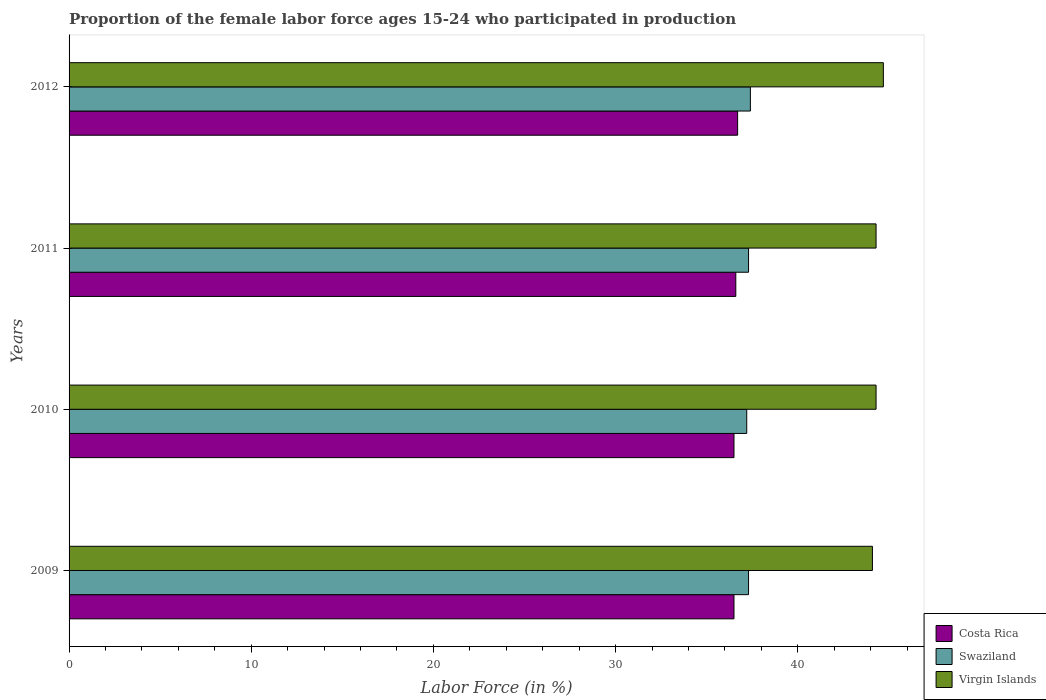How many different coloured bars are there?
Make the answer very short. 3. How many groups of bars are there?
Provide a succinct answer. 4. How many bars are there on the 4th tick from the top?
Provide a short and direct response. 3. How many bars are there on the 4th tick from the bottom?
Offer a terse response. 3. What is the proportion of the female labor force who participated in production in Virgin Islands in 2009?
Make the answer very short. 44.1. Across all years, what is the maximum proportion of the female labor force who participated in production in Virgin Islands?
Offer a very short reply. 44.7. Across all years, what is the minimum proportion of the female labor force who participated in production in Swaziland?
Your response must be concise. 37.2. In which year was the proportion of the female labor force who participated in production in Swaziland maximum?
Ensure brevity in your answer.  2012. In which year was the proportion of the female labor force who participated in production in Costa Rica minimum?
Your answer should be compact. 2009. What is the total proportion of the female labor force who participated in production in Costa Rica in the graph?
Your answer should be compact. 146.3. What is the difference between the proportion of the female labor force who participated in production in Swaziland in 2010 and the proportion of the female labor force who participated in production in Virgin Islands in 2012?
Your response must be concise. -7.5. What is the average proportion of the female labor force who participated in production in Virgin Islands per year?
Provide a short and direct response. 44.35. In the year 2012, what is the difference between the proportion of the female labor force who participated in production in Costa Rica and proportion of the female labor force who participated in production in Swaziland?
Give a very brief answer. -0.7. What is the ratio of the proportion of the female labor force who participated in production in Virgin Islands in 2011 to that in 2012?
Keep it short and to the point. 0.99. Is the difference between the proportion of the female labor force who participated in production in Costa Rica in 2009 and 2012 greater than the difference between the proportion of the female labor force who participated in production in Swaziland in 2009 and 2012?
Your response must be concise. No. What is the difference between the highest and the second highest proportion of the female labor force who participated in production in Virgin Islands?
Your answer should be compact. 0.4. What is the difference between the highest and the lowest proportion of the female labor force who participated in production in Swaziland?
Your answer should be very brief. 0.2. In how many years, is the proportion of the female labor force who participated in production in Virgin Islands greater than the average proportion of the female labor force who participated in production in Virgin Islands taken over all years?
Provide a succinct answer. 1. Is the sum of the proportion of the female labor force who participated in production in Swaziland in 2010 and 2012 greater than the maximum proportion of the female labor force who participated in production in Virgin Islands across all years?
Ensure brevity in your answer.  Yes. What does the 1st bar from the bottom in 2009 represents?
Ensure brevity in your answer.  Costa Rica. How many years are there in the graph?
Your answer should be very brief. 4. What is the difference between two consecutive major ticks on the X-axis?
Make the answer very short. 10. Does the graph contain grids?
Make the answer very short. No. How many legend labels are there?
Give a very brief answer. 3. What is the title of the graph?
Provide a short and direct response. Proportion of the female labor force ages 15-24 who participated in production. Does "Kosovo" appear as one of the legend labels in the graph?
Make the answer very short. No. What is the label or title of the Y-axis?
Keep it short and to the point. Years. What is the Labor Force (in %) of Costa Rica in 2009?
Ensure brevity in your answer.  36.5. What is the Labor Force (in %) in Swaziland in 2009?
Give a very brief answer. 37.3. What is the Labor Force (in %) of Virgin Islands in 2009?
Ensure brevity in your answer.  44.1. What is the Labor Force (in %) in Costa Rica in 2010?
Your answer should be very brief. 36.5. What is the Labor Force (in %) of Swaziland in 2010?
Offer a very short reply. 37.2. What is the Labor Force (in %) of Virgin Islands in 2010?
Give a very brief answer. 44.3. What is the Labor Force (in %) in Costa Rica in 2011?
Make the answer very short. 36.6. What is the Labor Force (in %) in Swaziland in 2011?
Give a very brief answer. 37.3. What is the Labor Force (in %) of Virgin Islands in 2011?
Offer a very short reply. 44.3. What is the Labor Force (in %) of Costa Rica in 2012?
Give a very brief answer. 36.7. What is the Labor Force (in %) in Swaziland in 2012?
Your answer should be compact. 37.4. What is the Labor Force (in %) of Virgin Islands in 2012?
Give a very brief answer. 44.7. Across all years, what is the maximum Labor Force (in %) of Costa Rica?
Make the answer very short. 36.7. Across all years, what is the maximum Labor Force (in %) of Swaziland?
Make the answer very short. 37.4. Across all years, what is the maximum Labor Force (in %) in Virgin Islands?
Your answer should be very brief. 44.7. Across all years, what is the minimum Labor Force (in %) in Costa Rica?
Your answer should be compact. 36.5. Across all years, what is the minimum Labor Force (in %) in Swaziland?
Keep it short and to the point. 37.2. Across all years, what is the minimum Labor Force (in %) in Virgin Islands?
Your answer should be compact. 44.1. What is the total Labor Force (in %) in Costa Rica in the graph?
Ensure brevity in your answer.  146.3. What is the total Labor Force (in %) in Swaziland in the graph?
Offer a terse response. 149.2. What is the total Labor Force (in %) of Virgin Islands in the graph?
Ensure brevity in your answer.  177.4. What is the difference between the Labor Force (in %) of Costa Rica in 2009 and that in 2010?
Provide a short and direct response. 0. What is the difference between the Labor Force (in %) in Swaziland in 2009 and that in 2010?
Offer a terse response. 0.1. What is the difference between the Labor Force (in %) in Virgin Islands in 2009 and that in 2010?
Ensure brevity in your answer.  -0.2. What is the difference between the Labor Force (in %) of Costa Rica in 2009 and that in 2011?
Offer a very short reply. -0.1. What is the difference between the Labor Force (in %) in Swaziland in 2009 and that in 2011?
Provide a succinct answer. 0. What is the difference between the Labor Force (in %) in Virgin Islands in 2009 and that in 2011?
Keep it short and to the point. -0.2. What is the difference between the Labor Force (in %) in Costa Rica in 2010 and that in 2011?
Provide a short and direct response. -0.1. What is the difference between the Labor Force (in %) of Swaziland in 2010 and that in 2011?
Offer a terse response. -0.1. What is the difference between the Labor Force (in %) of Swaziland in 2011 and that in 2012?
Offer a terse response. -0.1. What is the difference between the Labor Force (in %) in Virgin Islands in 2011 and that in 2012?
Your answer should be compact. -0.4. What is the difference between the Labor Force (in %) of Costa Rica in 2009 and the Labor Force (in %) of Swaziland in 2010?
Your response must be concise. -0.7. What is the difference between the Labor Force (in %) in Swaziland in 2009 and the Labor Force (in %) in Virgin Islands in 2010?
Make the answer very short. -7. What is the difference between the Labor Force (in %) of Costa Rica in 2009 and the Labor Force (in %) of Virgin Islands in 2011?
Your response must be concise. -7.8. What is the difference between the Labor Force (in %) in Swaziland in 2009 and the Labor Force (in %) in Virgin Islands in 2011?
Offer a very short reply. -7. What is the difference between the Labor Force (in %) in Costa Rica in 2009 and the Labor Force (in %) in Virgin Islands in 2012?
Make the answer very short. -8.2. What is the difference between the Labor Force (in %) of Costa Rica in 2010 and the Labor Force (in %) of Virgin Islands in 2011?
Ensure brevity in your answer.  -7.8. What is the difference between the Labor Force (in %) of Costa Rica in 2010 and the Labor Force (in %) of Virgin Islands in 2012?
Give a very brief answer. -8.2. What is the difference between the Labor Force (in %) of Swaziland in 2010 and the Labor Force (in %) of Virgin Islands in 2012?
Your answer should be compact. -7.5. What is the difference between the Labor Force (in %) of Costa Rica in 2011 and the Labor Force (in %) of Swaziland in 2012?
Offer a very short reply. -0.8. What is the difference between the Labor Force (in %) in Costa Rica in 2011 and the Labor Force (in %) in Virgin Islands in 2012?
Provide a short and direct response. -8.1. What is the difference between the Labor Force (in %) in Swaziland in 2011 and the Labor Force (in %) in Virgin Islands in 2012?
Offer a very short reply. -7.4. What is the average Labor Force (in %) of Costa Rica per year?
Offer a very short reply. 36.58. What is the average Labor Force (in %) in Swaziland per year?
Your answer should be very brief. 37.3. What is the average Labor Force (in %) in Virgin Islands per year?
Offer a very short reply. 44.35. In the year 2010, what is the difference between the Labor Force (in %) in Swaziland and Labor Force (in %) in Virgin Islands?
Your answer should be compact. -7.1. In the year 2011, what is the difference between the Labor Force (in %) of Costa Rica and Labor Force (in %) of Virgin Islands?
Your answer should be compact. -7.7. In the year 2012, what is the difference between the Labor Force (in %) of Costa Rica and Labor Force (in %) of Swaziland?
Your answer should be very brief. -0.7. In the year 2012, what is the difference between the Labor Force (in %) of Costa Rica and Labor Force (in %) of Virgin Islands?
Your answer should be compact. -8. In the year 2012, what is the difference between the Labor Force (in %) in Swaziland and Labor Force (in %) in Virgin Islands?
Provide a short and direct response. -7.3. What is the ratio of the Labor Force (in %) of Swaziland in 2009 to that in 2010?
Give a very brief answer. 1. What is the ratio of the Labor Force (in %) of Virgin Islands in 2009 to that in 2011?
Offer a very short reply. 1. What is the ratio of the Labor Force (in %) in Costa Rica in 2009 to that in 2012?
Offer a very short reply. 0.99. What is the ratio of the Labor Force (in %) of Swaziland in 2009 to that in 2012?
Ensure brevity in your answer.  1. What is the ratio of the Labor Force (in %) in Virgin Islands in 2009 to that in 2012?
Offer a terse response. 0.99. What is the ratio of the Labor Force (in %) of Swaziland in 2010 to that in 2011?
Keep it short and to the point. 1. What is the ratio of the Labor Force (in %) of Costa Rica in 2010 to that in 2012?
Ensure brevity in your answer.  0.99. What is the ratio of the Labor Force (in %) in Swaziland in 2010 to that in 2012?
Ensure brevity in your answer.  0.99. What is the ratio of the Labor Force (in %) of Virgin Islands in 2010 to that in 2012?
Your answer should be compact. 0.99. What is the ratio of the Labor Force (in %) of Virgin Islands in 2011 to that in 2012?
Ensure brevity in your answer.  0.99. What is the difference between the highest and the second highest Labor Force (in %) in Swaziland?
Offer a terse response. 0.1. What is the difference between the highest and the second highest Labor Force (in %) of Virgin Islands?
Give a very brief answer. 0.4. What is the difference between the highest and the lowest Labor Force (in %) of Costa Rica?
Provide a succinct answer. 0.2. What is the difference between the highest and the lowest Labor Force (in %) of Swaziland?
Your answer should be very brief. 0.2. What is the difference between the highest and the lowest Labor Force (in %) of Virgin Islands?
Your answer should be compact. 0.6. 